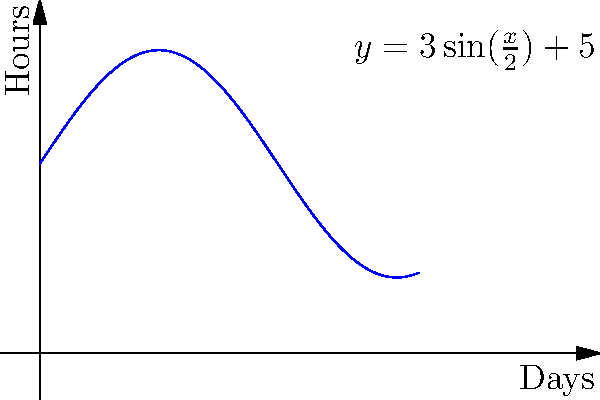As the curator of an international film festival, you've planned screenings over a 10-day period. The daily screening duration in hours is given by the function $f(x)=3\sin(\frac{x}{2})+5$, where $x$ represents the day number (0 ≤ x ≤ 10). Calculate the total runtime of the film festival in hours. To find the total runtime of the film festival, we need to calculate the definite integral of the given function over the interval [0, 10]. This represents the area under the curve of $f(x)=3\sin(\frac{x}{2})+5$ from x = 0 to x = 10.

Step 1: Set up the definite integral
$$\int_0^{10} (3\sin(\frac{x}{2})+5) dx$$

Step 2: Integrate the function
For the sine term: $\int 3\sin(\frac{x}{2}) dx = -6\cos(\frac{x}{2}) + C$
For the constant term: $\int 5 dx = 5x + C$

Combining these: $\int (3\sin(\frac{x}{2})+5) dx = -6\cos(\frac{x}{2}) + 5x + C$

Step 3: Apply the fundamental theorem of calculus
$$[-6\cos(\frac{x}{2}) + 5x]_0^{10}$$

Step 4: Evaluate the integral
$$[-6\cos(5) + 50] - [-6\cos(0) + 0]$$
$$= -6\cos(5) + 50 + 6$$
$$= -6\cos(5) + 56$$

Step 5: Calculate the final result
$$\approx 53.17 \text{ hours}$$
Answer: 53.17 hours 